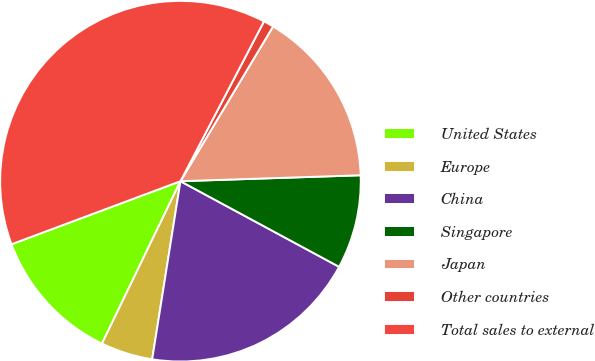<chart> <loc_0><loc_0><loc_500><loc_500><pie_chart><fcel>United States<fcel>Europe<fcel>China<fcel>Singapore<fcel>Japan<fcel>Other countries<fcel>Total sales to external<nl><fcel>12.15%<fcel>4.66%<fcel>19.63%<fcel>8.4%<fcel>15.89%<fcel>0.92%<fcel>38.35%<nl></chart> 